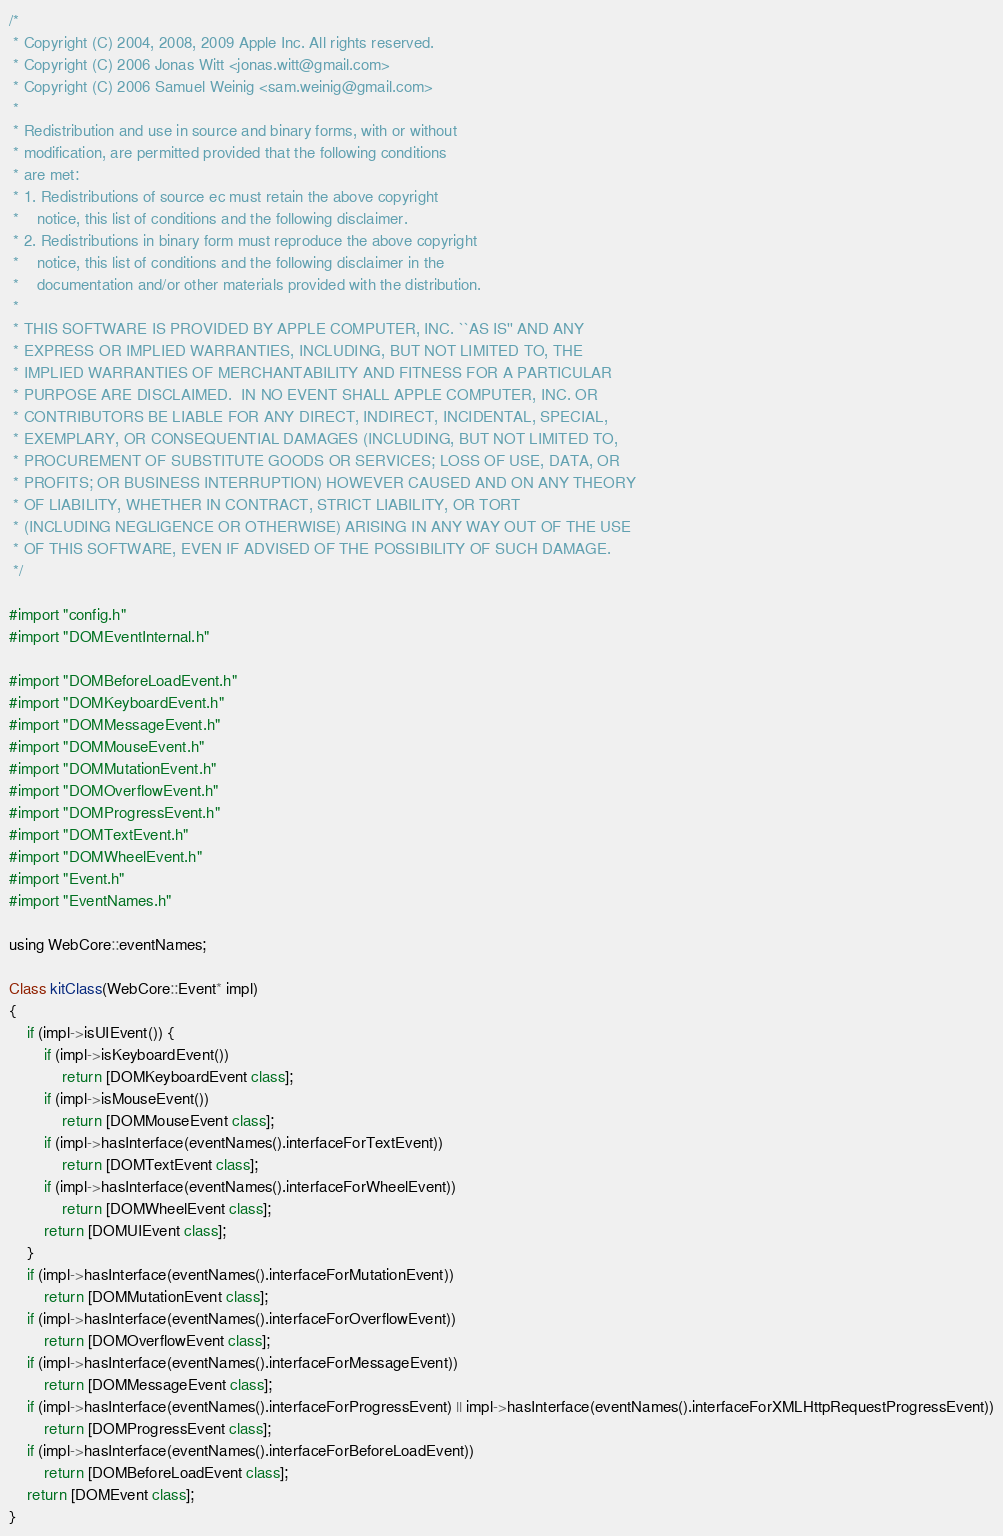Convert code to text. <code><loc_0><loc_0><loc_500><loc_500><_ObjectiveC_>/*
 * Copyright (C) 2004, 2008, 2009 Apple Inc. All rights reserved.
 * Copyright (C) 2006 Jonas Witt <jonas.witt@gmail.com>
 * Copyright (C) 2006 Samuel Weinig <sam.weinig@gmail.com>
 *
 * Redistribution and use in source and binary forms, with or without
 * modification, are permitted provided that the following conditions
 * are met:
 * 1. Redistributions of source ec must retain the above copyright
 *    notice, this list of conditions and the following disclaimer.
 * 2. Redistributions in binary form must reproduce the above copyright
 *    notice, this list of conditions and the following disclaimer in the
 *    documentation and/or other materials provided with the distribution.
 *
 * THIS SOFTWARE IS PROVIDED BY APPLE COMPUTER, INC. ``AS IS'' AND ANY
 * EXPRESS OR IMPLIED WARRANTIES, INCLUDING, BUT NOT LIMITED TO, THE
 * IMPLIED WARRANTIES OF MERCHANTABILITY AND FITNESS FOR A PARTICULAR
 * PURPOSE ARE DISCLAIMED.  IN NO EVENT SHALL APPLE COMPUTER, INC. OR
 * CONTRIBUTORS BE LIABLE FOR ANY DIRECT, INDIRECT, INCIDENTAL, SPECIAL,
 * EXEMPLARY, OR CONSEQUENTIAL DAMAGES (INCLUDING, BUT NOT LIMITED TO,
 * PROCUREMENT OF SUBSTITUTE GOODS OR SERVICES; LOSS OF USE, DATA, OR
 * PROFITS; OR BUSINESS INTERRUPTION) HOWEVER CAUSED AND ON ANY THEORY
 * OF LIABILITY, WHETHER IN CONTRACT, STRICT LIABILITY, OR TORT
 * (INCLUDING NEGLIGENCE OR OTHERWISE) ARISING IN ANY WAY OUT OF THE USE
 * OF THIS SOFTWARE, EVEN IF ADVISED OF THE POSSIBILITY OF SUCH DAMAGE. 
 */

#import "config.h"
#import "DOMEventInternal.h"

#import "DOMBeforeLoadEvent.h"
#import "DOMKeyboardEvent.h"
#import "DOMMessageEvent.h"
#import "DOMMouseEvent.h"
#import "DOMMutationEvent.h"
#import "DOMOverflowEvent.h"
#import "DOMProgressEvent.h"
#import "DOMTextEvent.h"
#import "DOMWheelEvent.h"
#import "Event.h"
#import "EventNames.h"

using WebCore::eventNames;

Class kitClass(WebCore::Event* impl)
{
    if (impl->isUIEvent()) {
        if (impl->isKeyboardEvent())
            return [DOMKeyboardEvent class];
        if (impl->isMouseEvent())
            return [DOMMouseEvent class];
        if (impl->hasInterface(eventNames().interfaceForTextEvent))
            return [DOMTextEvent class];
        if (impl->hasInterface(eventNames().interfaceForWheelEvent))
            return [DOMWheelEvent class];        
        return [DOMUIEvent class];
    }
    if (impl->hasInterface(eventNames().interfaceForMutationEvent))
        return [DOMMutationEvent class];
    if (impl->hasInterface(eventNames().interfaceForOverflowEvent))
        return [DOMOverflowEvent class];
    if (impl->hasInterface(eventNames().interfaceForMessageEvent))
        return [DOMMessageEvent class];
    if (impl->hasInterface(eventNames().interfaceForProgressEvent) || impl->hasInterface(eventNames().interfaceForXMLHttpRequestProgressEvent))
        return [DOMProgressEvent class];
    if (impl->hasInterface(eventNames().interfaceForBeforeLoadEvent))
        return [DOMBeforeLoadEvent class];
    return [DOMEvent class];
}
</code> 